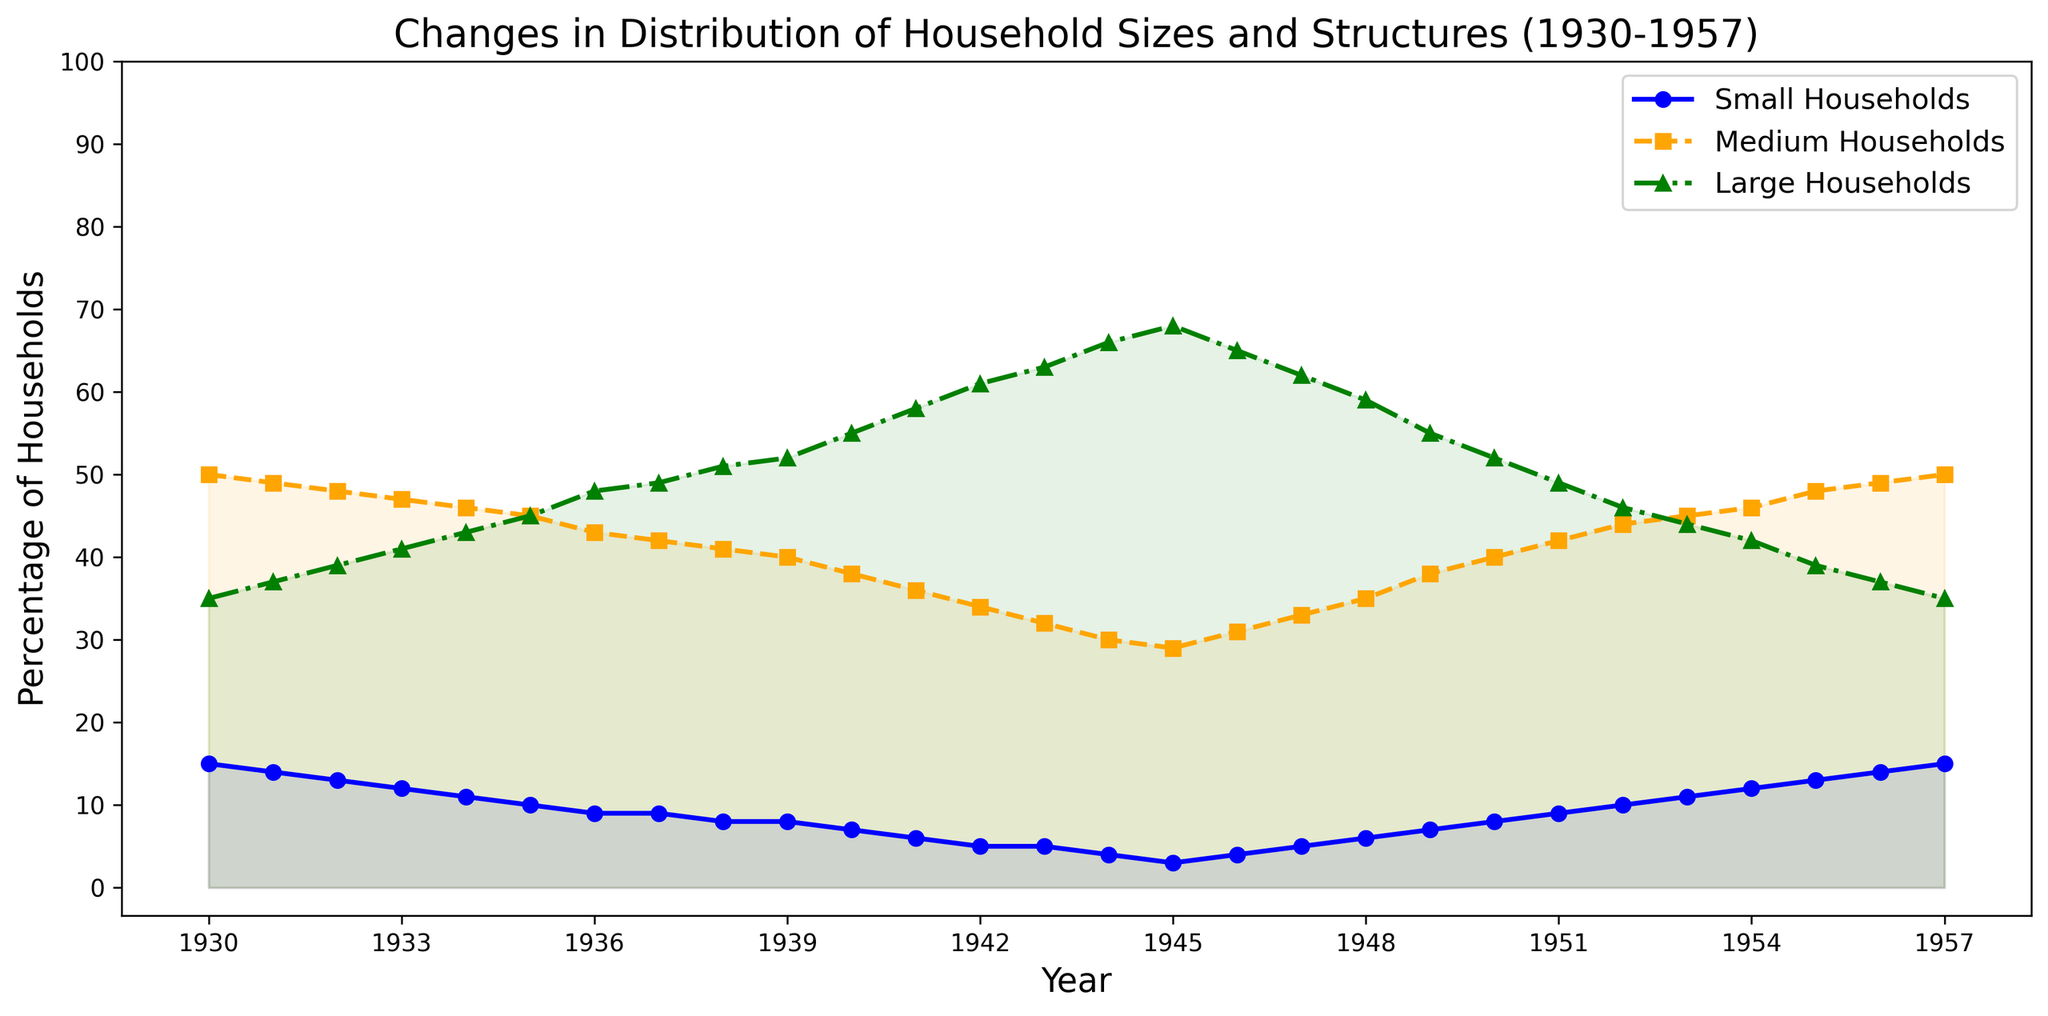Which year shows the lowest percentage of small households? To find the lowest percentage of small households, we look for the data point in the 'Small Households' line that is at its minimum on the y-axis. This occurs in 1945 with a value of 3%.
Answer: 1945 In which year do medium households start increasing again after their decline? We observe the 'Medium Households' line and see that it declines until 1945 and then starts to increase from 1946 onwards.
Answer: 1946 What was the percentage difference between large households in 1943 and 1957? The 'Large Households' line shows a percentage of 63 in 1943 and 35 in 1957. The difference is calculated as 63 - 35.
Answer: 28 During what period do you see the most significant increase in large households? The 'Large Households' line shows the steepest increase between 1939 and 1945, where it rises from 52% to 68%.
Answer: 1939-1945 Compare the percentage of small and medium households in 1940. Which was higher and by how much? In 1940, the figure shows small households at 7% and medium households at 38%. The difference is 38 - 7.
Answer: Medium households, by 31% How do the trends in medium and large households differ during the war years (1939-1945)? The 'Medium Households' line shows a consistent decline during these years, while the 'Large Households' line shows a consistent increase.
Answer: Medium households decrease, large households increase In which year do small households and large households have the same percentage? Observing the two lines, small and large households both have the same percentage of 9% in 1936.
Answer: 1936 What happens to the percentage of small and large households between 1952 and 1957? Between these years, the 'Small Households' line increases from 10% to 15%, and the 'Large Households' line decreases from 46% to 35%.
Answer: Small households increase, large households decrease How significantly did the medium households drop from 1939 to 1945? The 'Medium Households' line decreases from 40% to 29%. The difference is 40 - 29.
Answer: 11% Which household size saw the most fluctuation in distribution over the years? By looking at the three lines, the 'Large Households' line shows the most significant change, rising steeply from 35% to 68% and then falling back to 35%.
Answer: Large households 